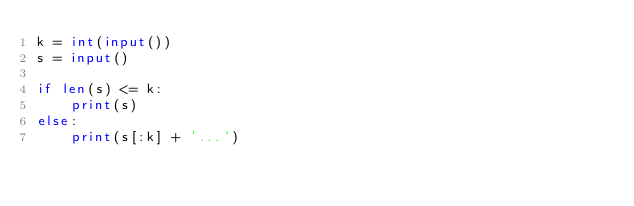<code> <loc_0><loc_0><loc_500><loc_500><_Python_>k = int(input())
s = input()

if len(s) <= k:
    print(s)
else:
    print(s[:k] + '...')
</code> 